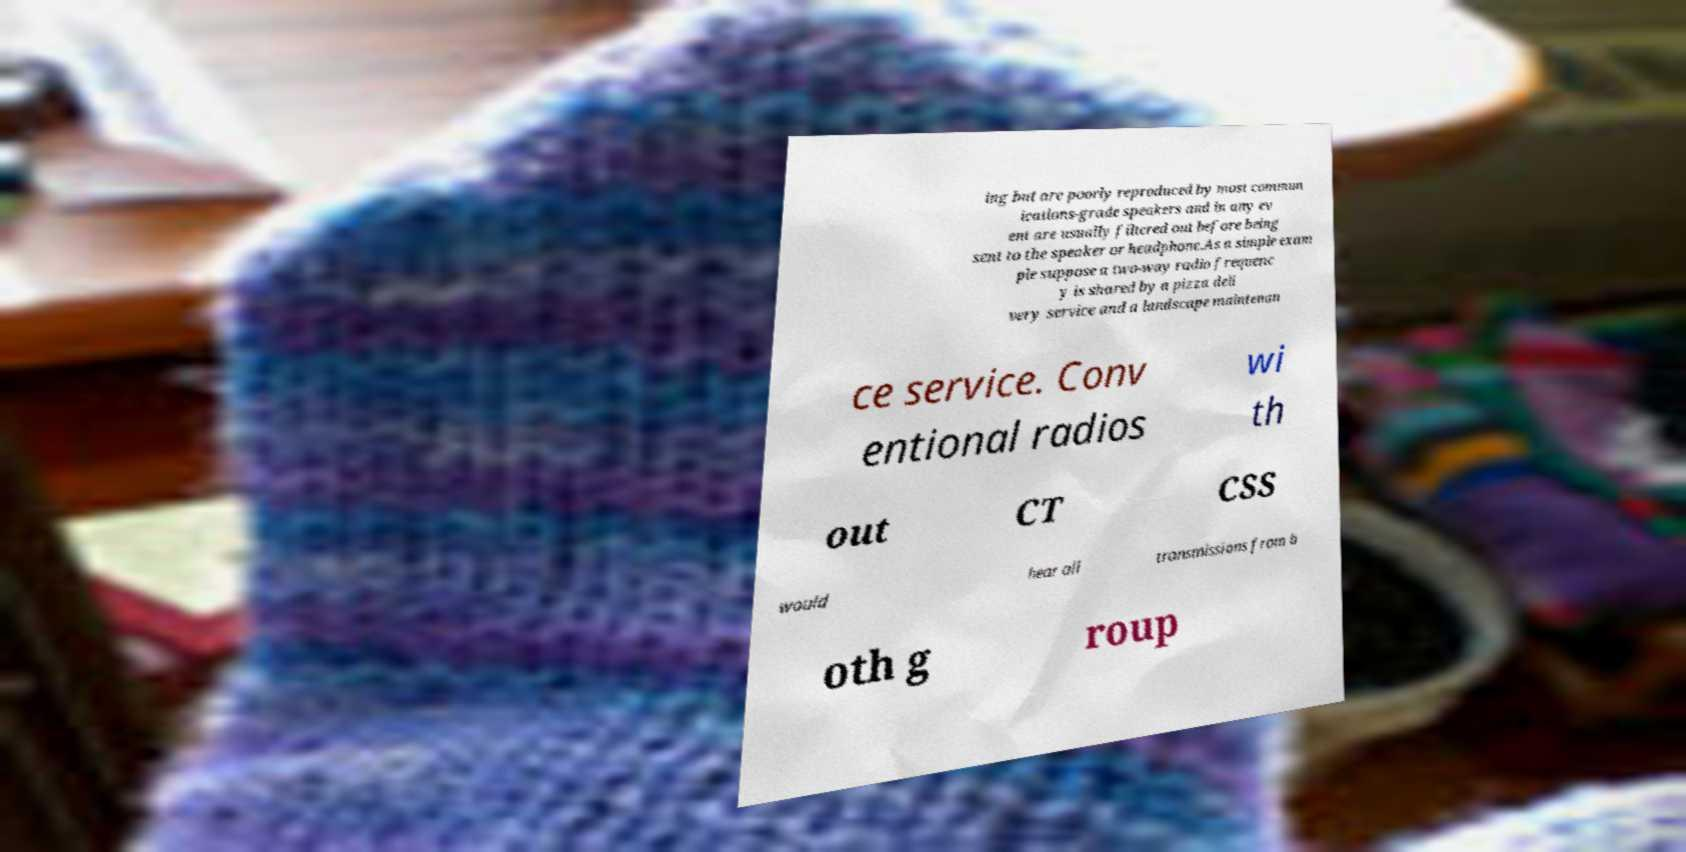Can you accurately transcribe the text from the provided image for me? ing but are poorly reproduced by most commun ications-grade speakers and in any ev ent are usually filtered out before being sent to the speaker or headphone.As a simple exam ple suppose a two-way radio frequenc y is shared by a pizza deli very service and a landscape maintenan ce service. Conv entional radios wi th out CT CSS would hear all transmissions from b oth g roup 